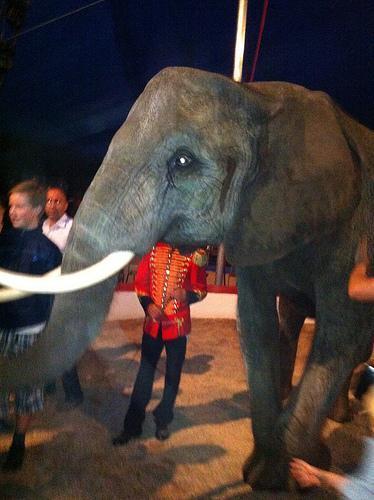How many tusks are shown?
Give a very brief answer. 2. 